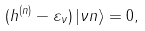<formula> <loc_0><loc_0><loc_500><loc_500>( h ^ { ( n ) } - \varepsilon _ { \nu } ) \left | \nu n \right \rangle = 0 ,</formula> 